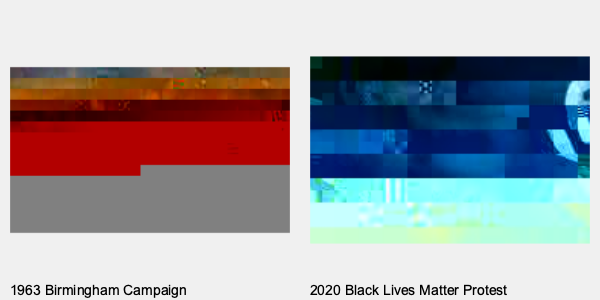Compare and contrast the two civil rights protest images shown. What key similarities and differences do you observe in terms of the protesters' tactics, the response from authorities, and the overall context of each era? How do these images reflect the evolution of the civil rights movement over time? To analyze these images, let's break it down step-by-step:

1. Tactics:
   - 1963: Peaceful protest, protesters linked arms, facing police
   - 2020: Peaceful protest, protesters holding signs, facing police

2. Police response:
   - 1963: Police using fire hoses on protesters
   - 2020: Police in riot gear, no visible use of force in this image

3. Protesters:
   - 1963: Primarily African American protesters
   - 2020: Diverse group of protesters

4. Context:
   - 1963: Birmingham Campaign, part of the broader Civil Rights Movement
   - 2020: Black Lives Matter movement, addressing ongoing racial injustice

5. Similarities:
   - Both show peaceful protesters confronting law enforcement
   - Both movements seek racial equality and justice

6. Differences:
   - Tactics used by police (fire hoses vs. riot gear)
   - Diversity of protesters
   - Use of signs and messaging in 2020 protest

7. Evolution of the movement:
   - Broader participation in 2020
   - More visible messaging through signs
   - Change in police tactics, though still confrontational

8. Continuity:
   - Both images show the ongoing struggle for racial equality
   - Peaceful protest remains a key strategy

The images reflect the evolution of the civil rights movement by showing how tactics, participation, and police responses have changed, while also highlighting the continued need for protest against racial injustice.
Answer: Both images show peaceful protests against racial injustice, but the 2020 protest has more diverse participation, visible messaging, and different police tactics, reflecting the evolution of the civil rights movement while highlighting ongoing struggles. 